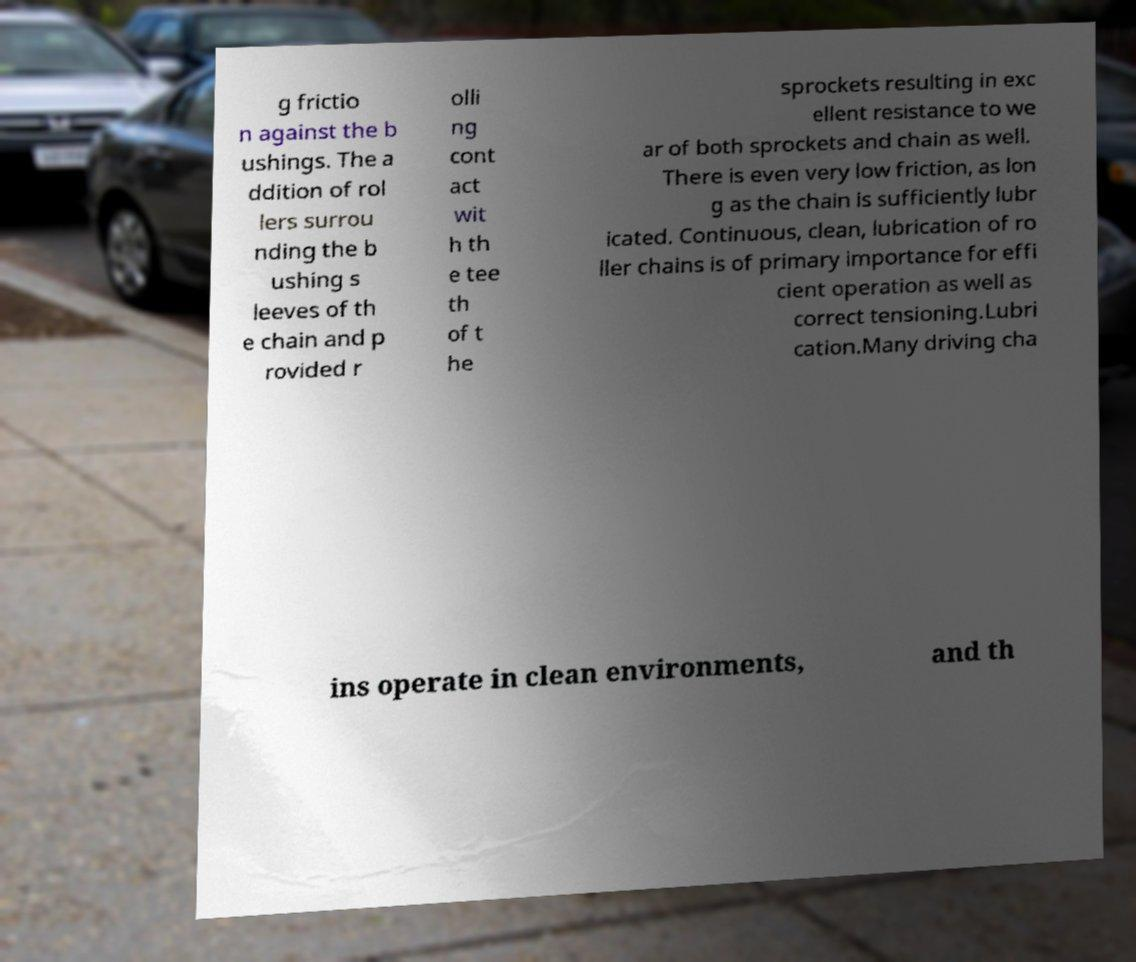What messages or text are displayed in this image? I need them in a readable, typed format. g frictio n against the b ushings. The a ddition of rol lers surrou nding the b ushing s leeves of th e chain and p rovided r olli ng cont act wit h th e tee th of t he sprockets resulting in exc ellent resistance to we ar of both sprockets and chain as well. There is even very low friction, as lon g as the chain is sufficiently lubr icated. Continuous, clean, lubrication of ro ller chains is of primary importance for effi cient operation as well as correct tensioning.Lubri cation.Many driving cha ins operate in clean environments, and th 